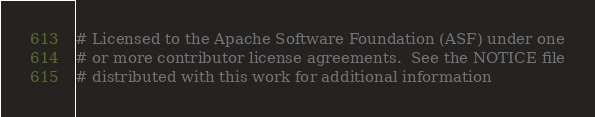Convert code to text. <code><loc_0><loc_0><loc_500><loc_500><_Python_># Licensed to the Apache Software Foundation (ASF) under one
# or more contributor license agreements.  See the NOTICE file
# distributed with this work for additional information</code> 